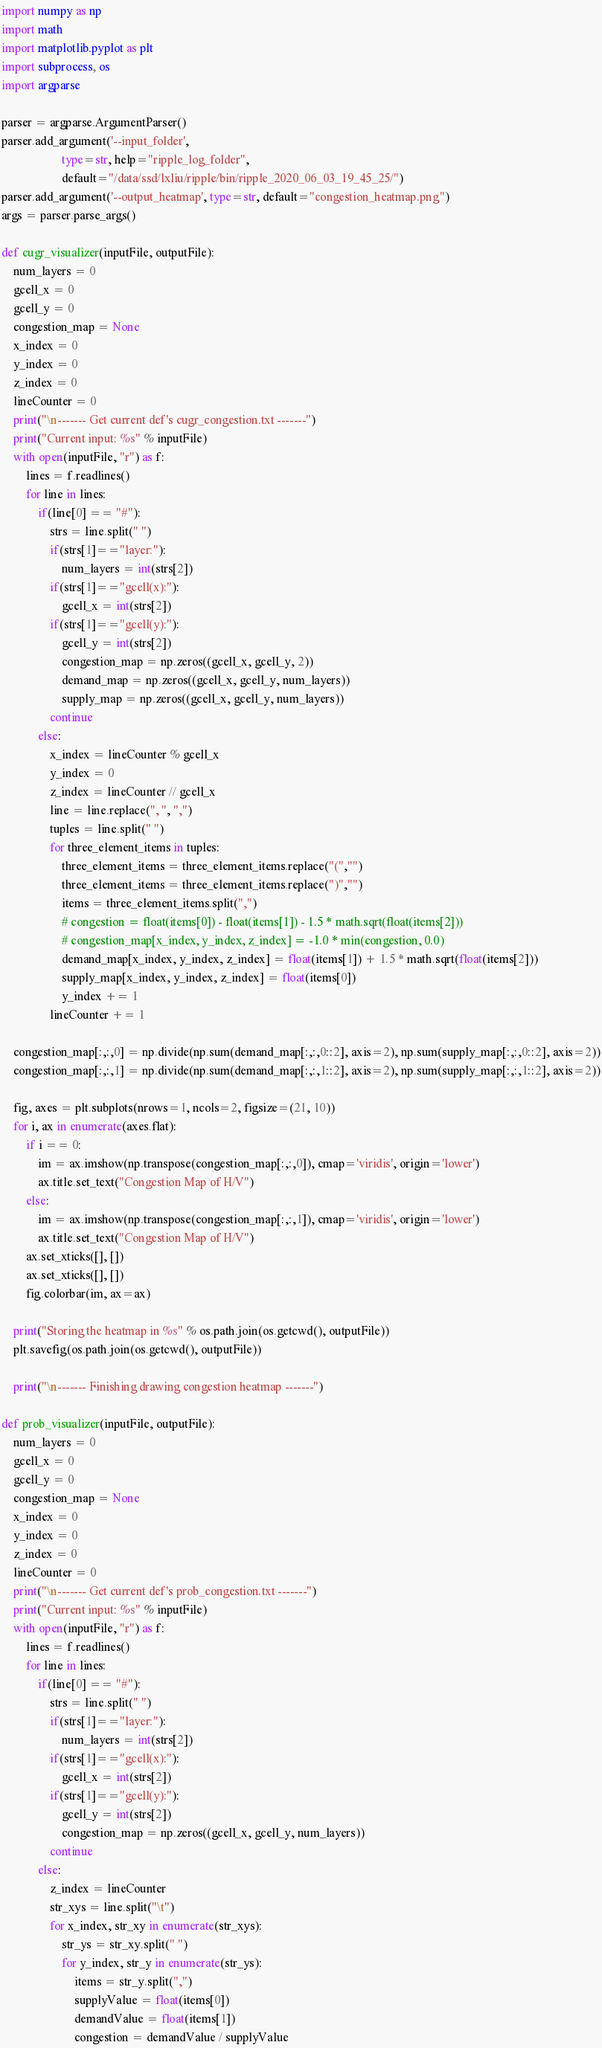Convert code to text. <code><loc_0><loc_0><loc_500><loc_500><_Python_>import numpy as np
import math
import matplotlib.pyplot as plt
import subprocess, os
import argparse

parser = argparse.ArgumentParser()
parser.add_argument('--input_folder', 
                    type=str, help="ripple_log_folder", 
                    default="/data/ssd/lxliu/ripple/bin/ripple_2020_06_03_19_45_25/")
parser.add_argument('--output_heatmap', type=str, default="congestion_heatmap.png")
args = parser.parse_args()

def cugr_visualizer(inputFile, outputFile):
    num_layers = 0
    gcell_x = 0
    gcell_y = 0
    congestion_map = None
    x_index = 0
    y_index = 0
    z_index = 0
    lineCounter = 0
    print("\n------- Get current def's cugr_congestion.txt -------")
    print("Current input: %s" % inputFile)
    with open(inputFile, "r") as f:
        lines = f.readlines()
        for line in lines:
            if(line[0] == "#"):
                strs = line.split(" ")
                if(strs[1]=="layer:"):
                    num_layers = int(strs[2])
                if(strs[1]=="gcell(x):"):
                    gcell_x = int(strs[2])
                if(strs[1]=="gcell(y):"):
                    gcell_y = int(strs[2])
                    congestion_map = np.zeros((gcell_x, gcell_y, 2))
                    demand_map = np.zeros((gcell_x, gcell_y, num_layers))
                    supply_map = np.zeros((gcell_x, gcell_y, num_layers))
                continue
            else:
                x_index = lineCounter % gcell_x
                y_index = 0
                z_index = lineCounter // gcell_x
                line = line.replace(", ", ",")
                tuples = line.split(" ")
                for three_element_items in tuples:
                    three_element_items = three_element_items.replace("(","")
                    three_element_items = three_element_items.replace(")","")
                    items = three_element_items.split(",")
                    # congestion = float(items[0]) - float(items[1]) - 1.5 * math.sqrt(float(items[2]))
                    # congestion_map[x_index, y_index, z_index] = -1.0 * min(congestion, 0.0)
                    demand_map[x_index, y_index, z_index] = float(items[1]) + 1.5 * math.sqrt(float(items[2]))
                    supply_map[x_index, y_index, z_index] = float(items[0])
                    y_index += 1
                lineCounter += 1

    congestion_map[:,:,0] = np.divide(np.sum(demand_map[:,:,0::2], axis=2), np.sum(supply_map[:,:,0::2], axis=2))
    congestion_map[:,:,1] = np.divide(np.sum(demand_map[:,:,1::2], axis=2), np.sum(supply_map[:,:,1::2], axis=2))

    fig, axes = plt.subplots(nrows=1, ncols=2, figsize=(21, 10))
    for i, ax in enumerate(axes.flat):
        if i == 0:
            im = ax.imshow(np.transpose(congestion_map[:,:,0]), cmap='viridis', origin='lower')
            ax.title.set_text("Congestion Map of H/V")
        else:
            im = ax.imshow(np.transpose(congestion_map[:,:,1]), cmap='viridis', origin='lower')
            ax.title.set_text("Congestion Map of H/V")
        ax.set_xticks([], [])
        ax.set_xticks([], [])
        fig.colorbar(im, ax=ax)

    print("Storing the heatmap in %s" % os.path.join(os.getcwd(), outputFile))
    plt.savefig(os.path.join(os.getcwd(), outputFile))

    print("\n------- Finishing drawing congestion heatmap -------")

def prob_visualizer(inputFile, outputFile):
    num_layers = 0
    gcell_x = 0
    gcell_y = 0
    congestion_map = None
    x_index = 0
    y_index = 0
    z_index = 0
    lineCounter = 0
    print("\n------- Get current def's prob_congestion.txt -------")
    print("Current input: %s" % inputFile)
    with open(inputFile, "r") as f:
        lines = f.readlines()
        for line in lines:
            if(line[0] == "#"):
                strs = line.split(" ")
                if(strs[1]=="layer:"):
                    num_layers = int(strs[2])
                if(strs[1]=="gcell(x):"):
                    gcell_x = int(strs[2])
                if(strs[1]=="gcell(y):"):
                    gcell_y = int(strs[2])
                    congestion_map = np.zeros((gcell_x, gcell_y, num_layers))
                continue
            else:
                z_index = lineCounter
                str_xys = line.split("\t")
                for x_index, str_xy in enumerate(str_xys):
                    str_ys = str_xy.split(" ")
                    for y_index, str_y in enumerate(str_ys):
                        items = str_y.split(",")
                        supplyValue = float(items[0])
                        demandValue = float(items[1]) 
                        congestion = demandValue / supplyValue</code> 